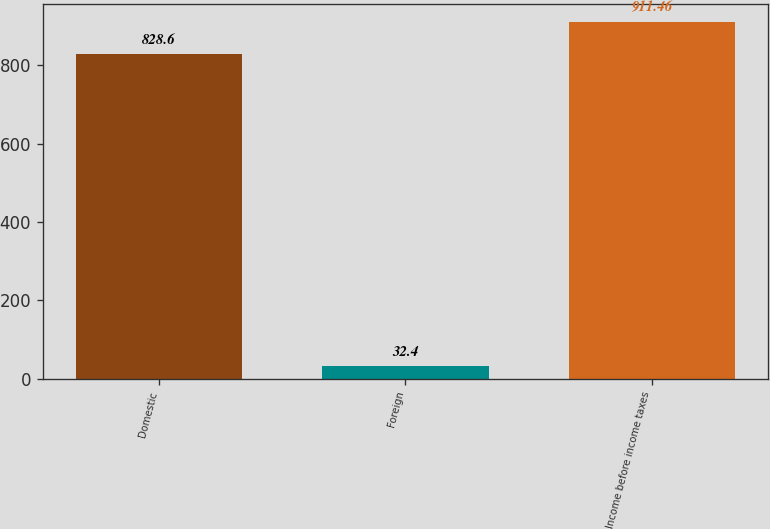<chart> <loc_0><loc_0><loc_500><loc_500><bar_chart><fcel>Domestic<fcel>Foreign<fcel>Income before income taxes<nl><fcel>828.6<fcel>32.4<fcel>911.46<nl></chart> 